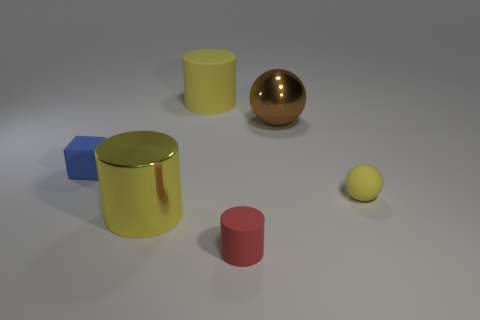What number of other things are there of the same shape as the red matte object? There are two other objects in the image that share the same cylindrical shape as the red matte object: one is yellow and slightly larger, and the other is blue and much smaller. 